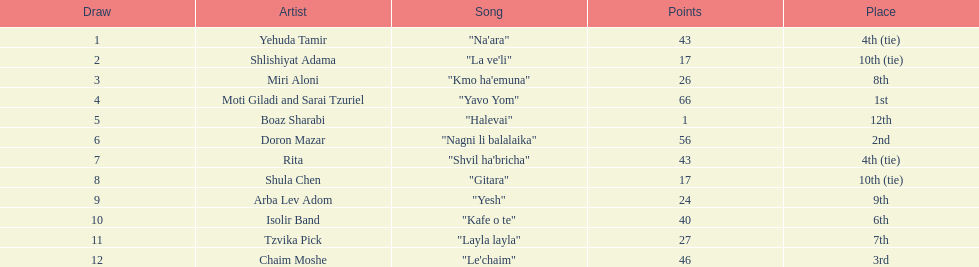What is the name of the song listed before the song "yesh"? "Gitara". 